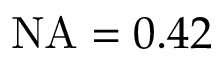Convert formula to latex. <formula><loc_0><loc_0><loc_500><loc_500>N A = 0 . 4 2</formula> 